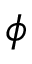Convert formula to latex. <formula><loc_0><loc_0><loc_500><loc_500>\phi</formula> 